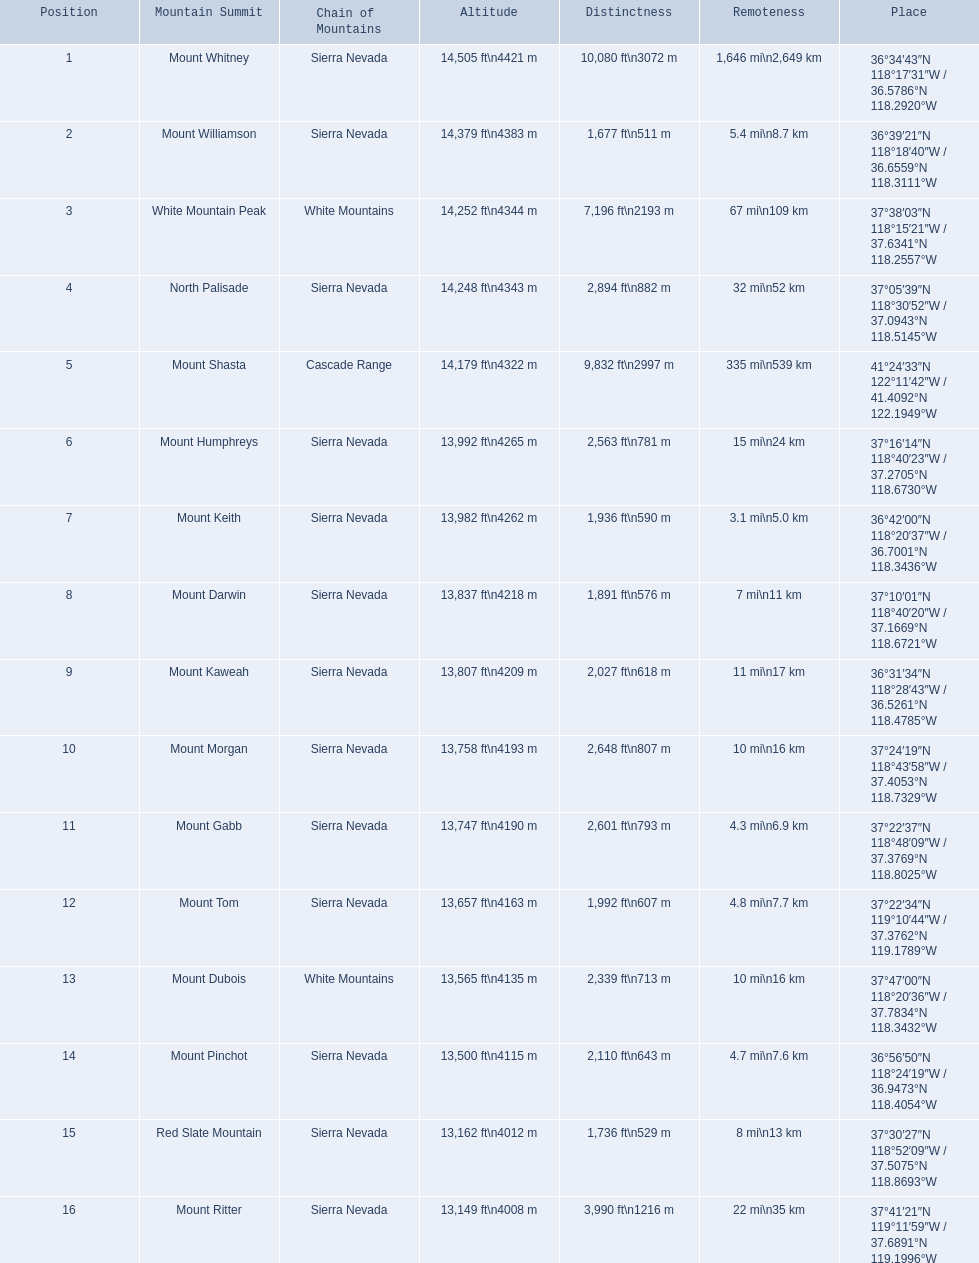What are the mountain peaks? Mount Whitney, Mount Williamson, White Mountain Peak, North Palisade, Mount Shasta, Mount Humphreys, Mount Keith, Mount Darwin, Mount Kaweah, Mount Morgan, Mount Gabb, Mount Tom, Mount Dubois, Mount Pinchot, Red Slate Mountain, Mount Ritter. Of these, which one has a prominence more than 10,000 ft? Mount Whitney. 